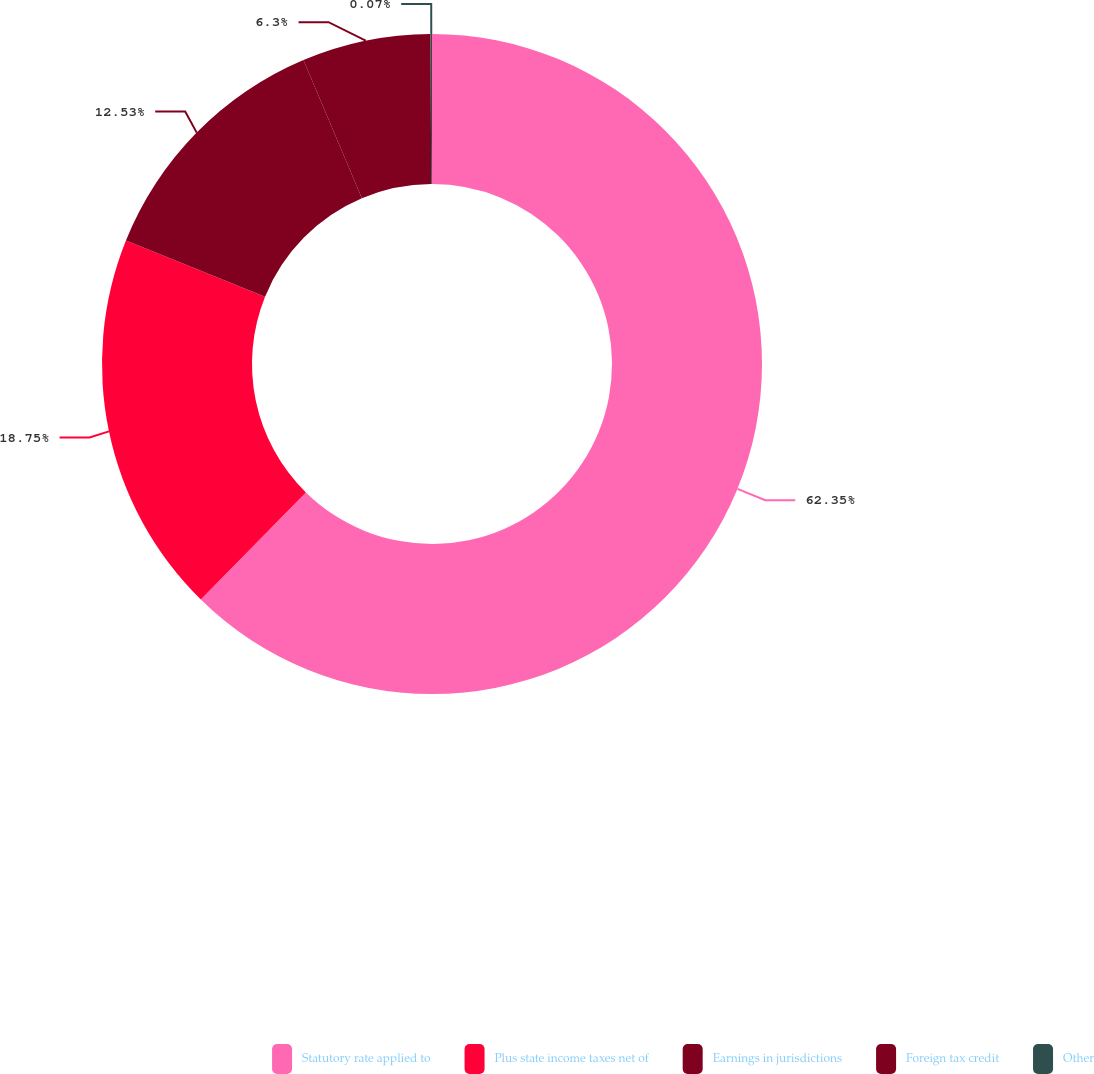<chart> <loc_0><loc_0><loc_500><loc_500><pie_chart><fcel>Statutory rate applied to<fcel>Plus state income taxes net of<fcel>Earnings in jurisdictions<fcel>Foreign tax credit<fcel>Other<nl><fcel>62.36%<fcel>18.75%<fcel>12.53%<fcel>6.3%<fcel>0.07%<nl></chart> 